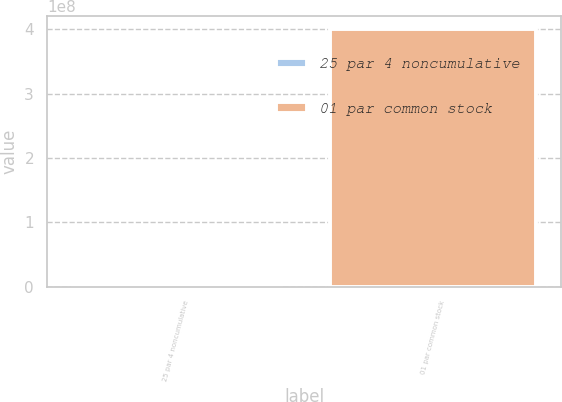Convert chart to OTSL. <chart><loc_0><loc_0><loc_500><loc_500><bar_chart><fcel>25 par 4 noncumulative<fcel>01 par common stock<nl><fcel>840000<fcel>4e+08<nl></chart> 